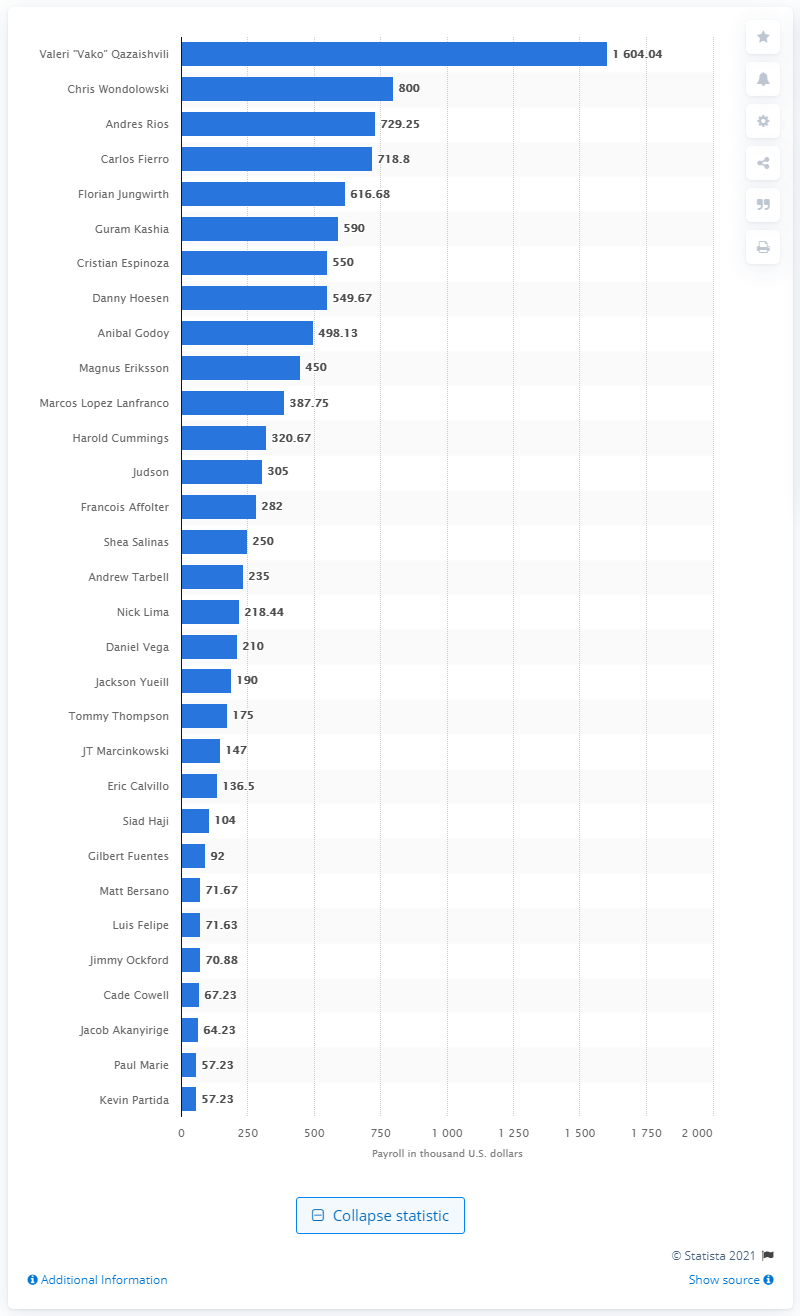Identify some key points in this picture. Valeri "Vako" Qazaishvili received a salary of 1.6 million dollars. 